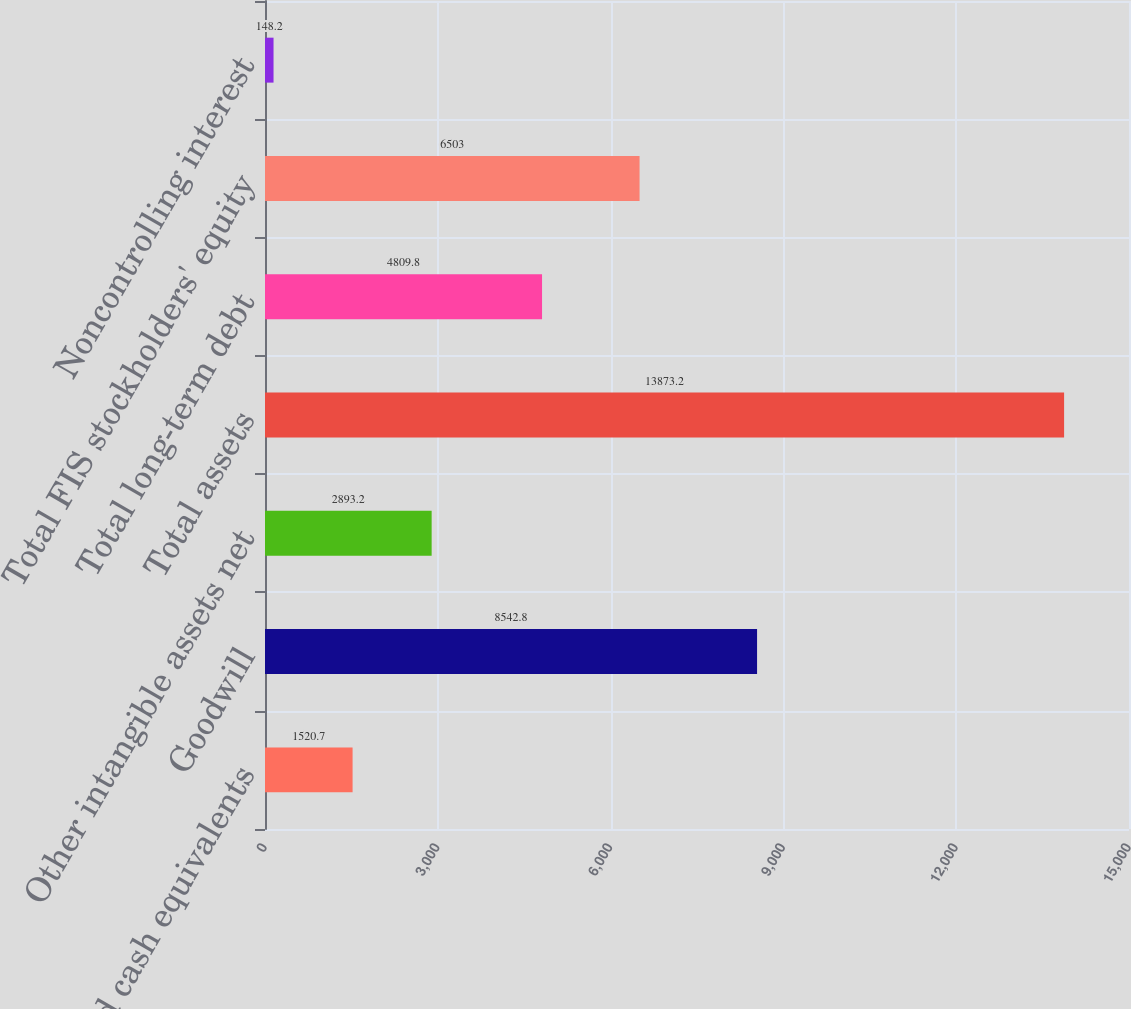Convert chart. <chart><loc_0><loc_0><loc_500><loc_500><bar_chart><fcel>Cash and cash equivalents<fcel>Goodwill<fcel>Other intangible assets net<fcel>Total assets<fcel>Total long-term debt<fcel>Total FIS stockholders' equity<fcel>Noncontrolling interest<nl><fcel>1520.7<fcel>8542.8<fcel>2893.2<fcel>13873.2<fcel>4809.8<fcel>6503<fcel>148.2<nl></chart> 